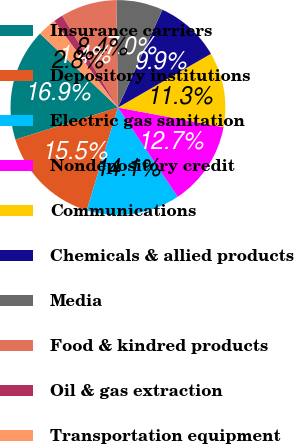<chart> <loc_0><loc_0><loc_500><loc_500><pie_chart><fcel>Insurance carriers<fcel>Depository institutions<fcel>Electric gas sanitation<fcel>Nondepository credit<fcel>Communications<fcel>Chemicals & allied products<fcel>Media<fcel>Food & kindred products<fcel>Oil & gas extraction<fcel>Transportation equipment<nl><fcel>16.9%<fcel>15.49%<fcel>14.08%<fcel>12.68%<fcel>11.27%<fcel>9.86%<fcel>7.04%<fcel>8.45%<fcel>1.41%<fcel>2.82%<nl></chart> 